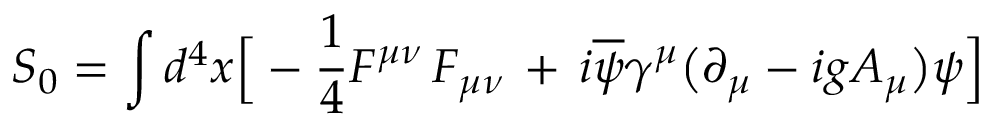<formula> <loc_0><loc_0><loc_500><loc_500>S _ { 0 } = \int d ^ { 4 } x \left [ - { \frac { 1 } { 4 } } F ^ { \mu \nu } \, F _ { \mu \nu } \, + \, i \overline { \psi } \gamma ^ { \mu } \left ( \partial _ { \mu } - i g A _ { \mu } \right ) \psi \right ]</formula> 